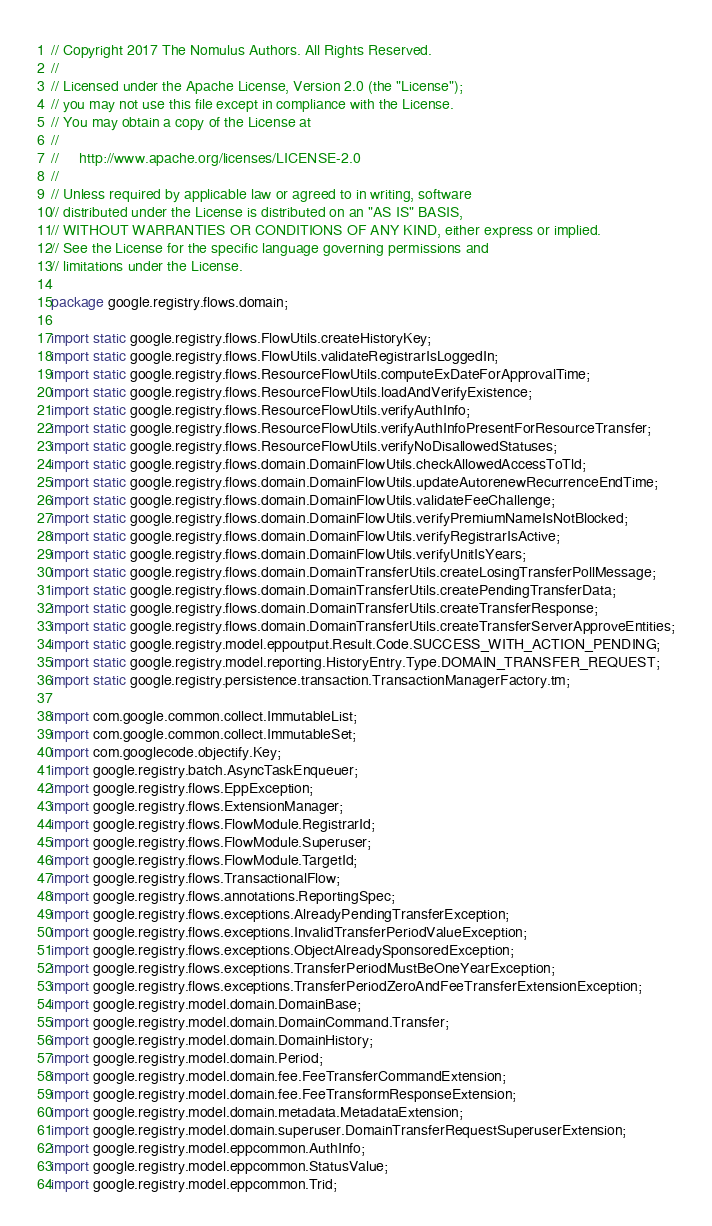<code> <loc_0><loc_0><loc_500><loc_500><_Java_>// Copyright 2017 The Nomulus Authors. All Rights Reserved.
//
// Licensed under the Apache License, Version 2.0 (the "License");
// you may not use this file except in compliance with the License.
// You may obtain a copy of the License at
//
//     http://www.apache.org/licenses/LICENSE-2.0
//
// Unless required by applicable law or agreed to in writing, software
// distributed under the License is distributed on an "AS IS" BASIS,
// WITHOUT WARRANTIES OR CONDITIONS OF ANY KIND, either express or implied.
// See the License for the specific language governing permissions and
// limitations under the License.

package google.registry.flows.domain;

import static google.registry.flows.FlowUtils.createHistoryKey;
import static google.registry.flows.FlowUtils.validateRegistrarIsLoggedIn;
import static google.registry.flows.ResourceFlowUtils.computeExDateForApprovalTime;
import static google.registry.flows.ResourceFlowUtils.loadAndVerifyExistence;
import static google.registry.flows.ResourceFlowUtils.verifyAuthInfo;
import static google.registry.flows.ResourceFlowUtils.verifyAuthInfoPresentForResourceTransfer;
import static google.registry.flows.ResourceFlowUtils.verifyNoDisallowedStatuses;
import static google.registry.flows.domain.DomainFlowUtils.checkAllowedAccessToTld;
import static google.registry.flows.domain.DomainFlowUtils.updateAutorenewRecurrenceEndTime;
import static google.registry.flows.domain.DomainFlowUtils.validateFeeChallenge;
import static google.registry.flows.domain.DomainFlowUtils.verifyPremiumNameIsNotBlocked;
import static google.registry.flows.domain.DomainFlowUtils.verifyRegistrarIsActive;
import static google.registry.flows.domain.DomainFlowUtils.verifyUnitIsYears;
import static google.registry.flows.domain.DomainTransferUtils.createLosingTransferPollMessage;
import static google.registry.flows.domain.DomainTransferUtils.createPendingTransferData;
import static google.registry.flows.domain.DomainTransferUtils.createTransferResponse;
import static google.registry.flows.domain.DomainTransferUtils.createTransferServerApproveEntities;
import static google.registry.model.eppoutput.Result.Code.SUCCESS_WITH_ACTION_PENDING;
import static google.registry.model.reporting.HistoryEntry.Type.DOMAIN_TRANSFER_REQUEST;
import static google.registry.persistence.transaction.TransactionManagerFactory.tm;

import com.google.common.collect.ImmutableList;
import com.google.common.collect.ImmutableSet;
import com.googlecode.objectify.Key;
import google.registry.batch.AsyncTaskEnqueuer;
import google.registry.flows.EppException;
import google.registry.flows.ExtensionManager;
import google.registry.flows.FlowModule.RegistrarId;
import google.registry.flows.FlowModule.Superuser;
import google.registry.flows.FlowModule.TargetId;
import google.registry.flows.TransactionalFlow;
import google.registry.flows.annotations.ReportingSpec;
import google.registry.flows.exceptions.AlreadyPendingTransferException;
import google.registry.flows.exceptions.InvalidTransferPeriodValueException;
import google.registry.flows.exceptions.ObjectAlreadySponsoredException;
import google.registry.flows.exceptions.TransferPeriodMustBeOneYearException;
import google.registry.flows.exceptions.TransferPeriodZeroAndFeeTransferExtensionException;
import google.registry.model.domain.DomainBase;
import google.registry.model.domain.DomainCommand.Transfer;
import google.registry.model.domain.DomainHistory;
import google.registry.model.domain.Period;
import google.registry.model.domain.fee.FeeTransferCommandExtension;
import google.registry.model.domain.fee.FeeTransformResponseExtension;
import google.registry.model.domain.metadata.MetadataExtension;
import google.registry.model.domain.superuser.DomainTransferRequestSuperuserExtension;
import google.registry.model.eppcommon.AuthInfo;
import google.registry.model.eppcommon.StatusValue;
import google.registry.model.eppcommon.Trid;</code> 